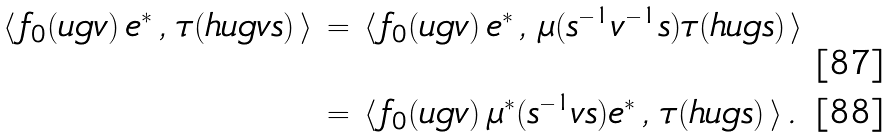<formula> <loc_0><loc_0><loc_500><loc_500>\langle \, f _ { 0 } ( u g v ) \, e ^ { * } \, , \, \tau ( h u g v s ) \, \rangle \, & = \, \langle \, f _ { 0 } ( u g v ) \, e ^ { * } \, , \, \mu ( s ^ { - 1 } v ^ { - 1 } s ) \tau ( h u g s ) \, \rangle \\ & = \, \langle \, f _ { 0 } ( u g v ) \, \mu ^ { * } ( s ^ { - 1 } v s ) e ^ { * } \, , \, \tau ( h u g s ) \, \rangle \, .</formula> 